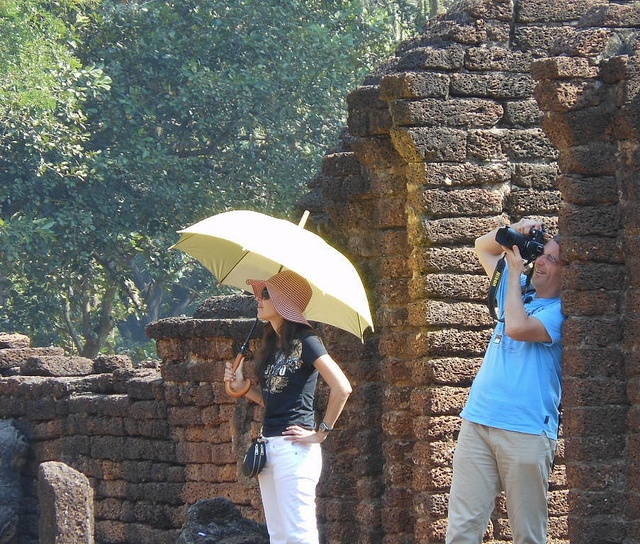Describe the objects in this image and their specific colors. I can see people in khaki, darkgray, lightblue, and gray tones, people in khaki, lavender, black, and gray tones, umbrella in khaki, white, and tan tones, and handbag in khaki, black, gray, and darkgray tones in this image. 